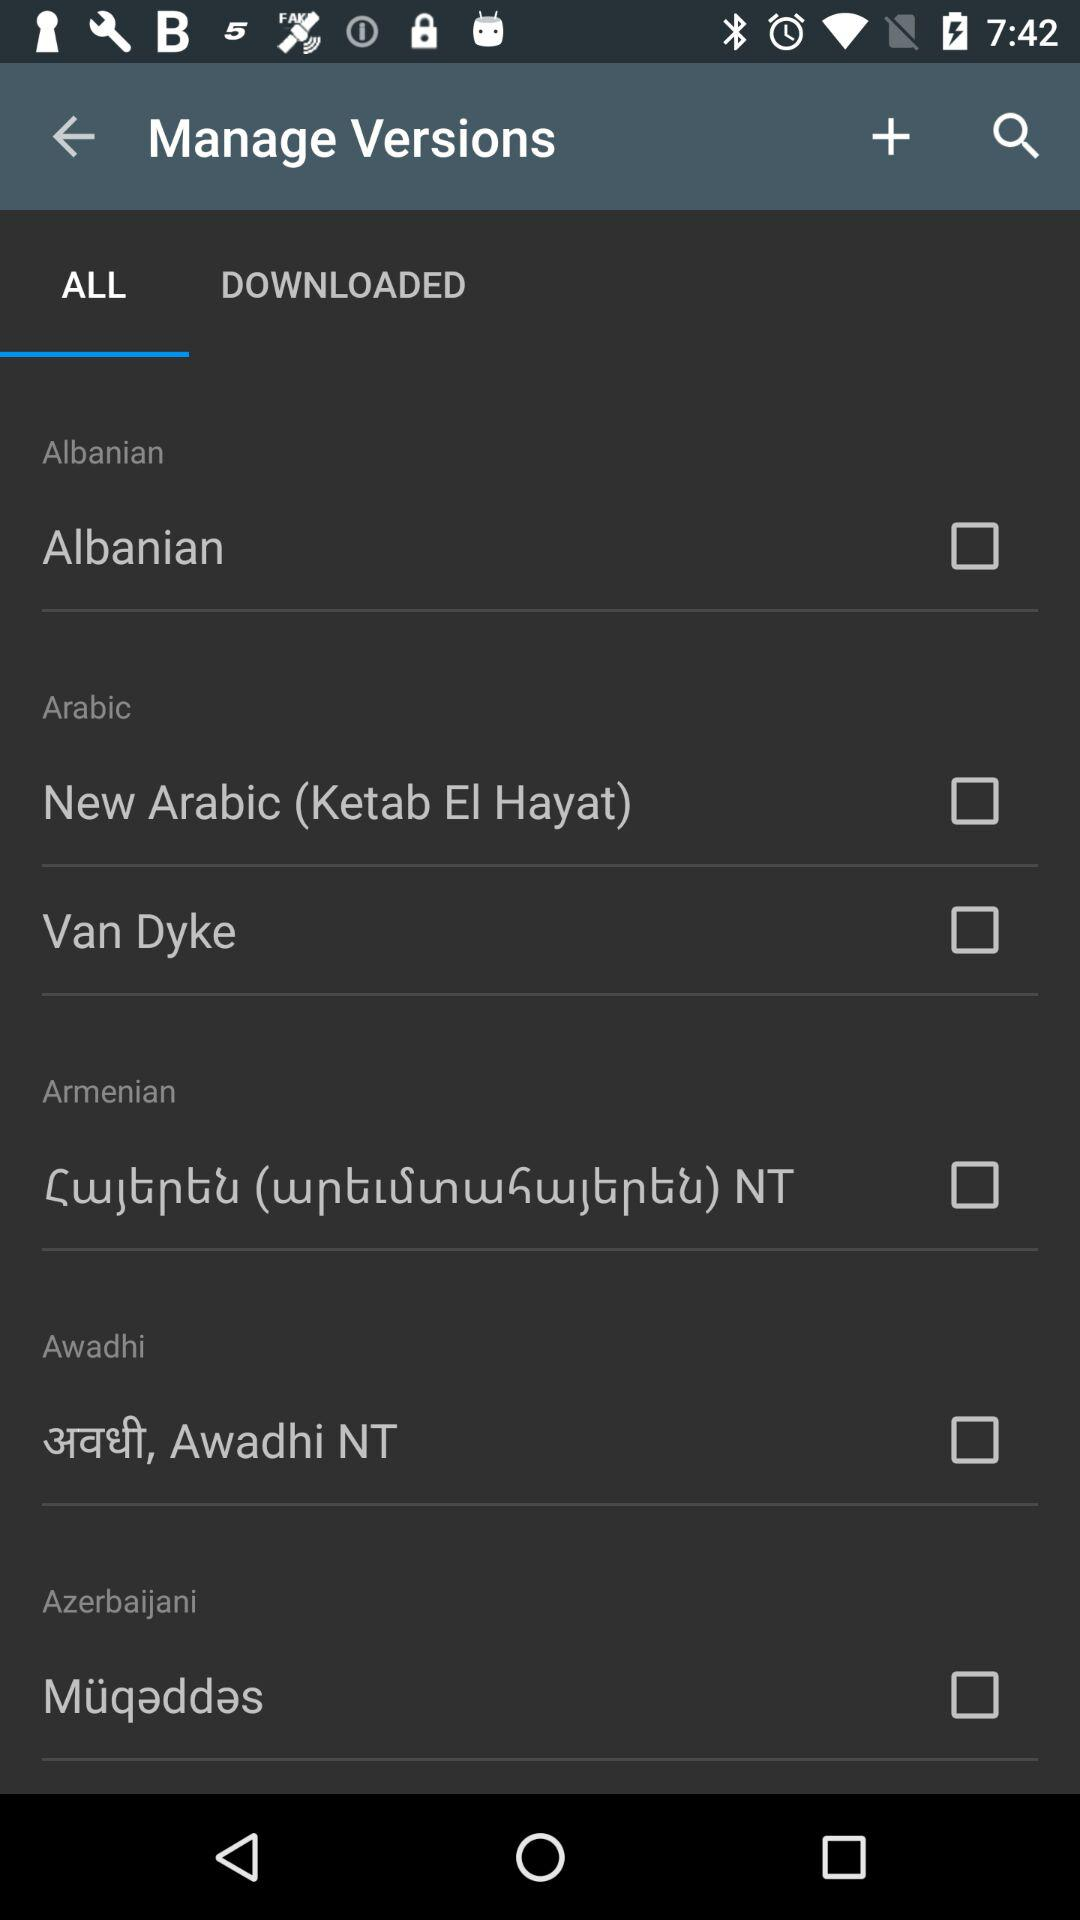What is the status of the "Van Dyke"? The status is "off". 